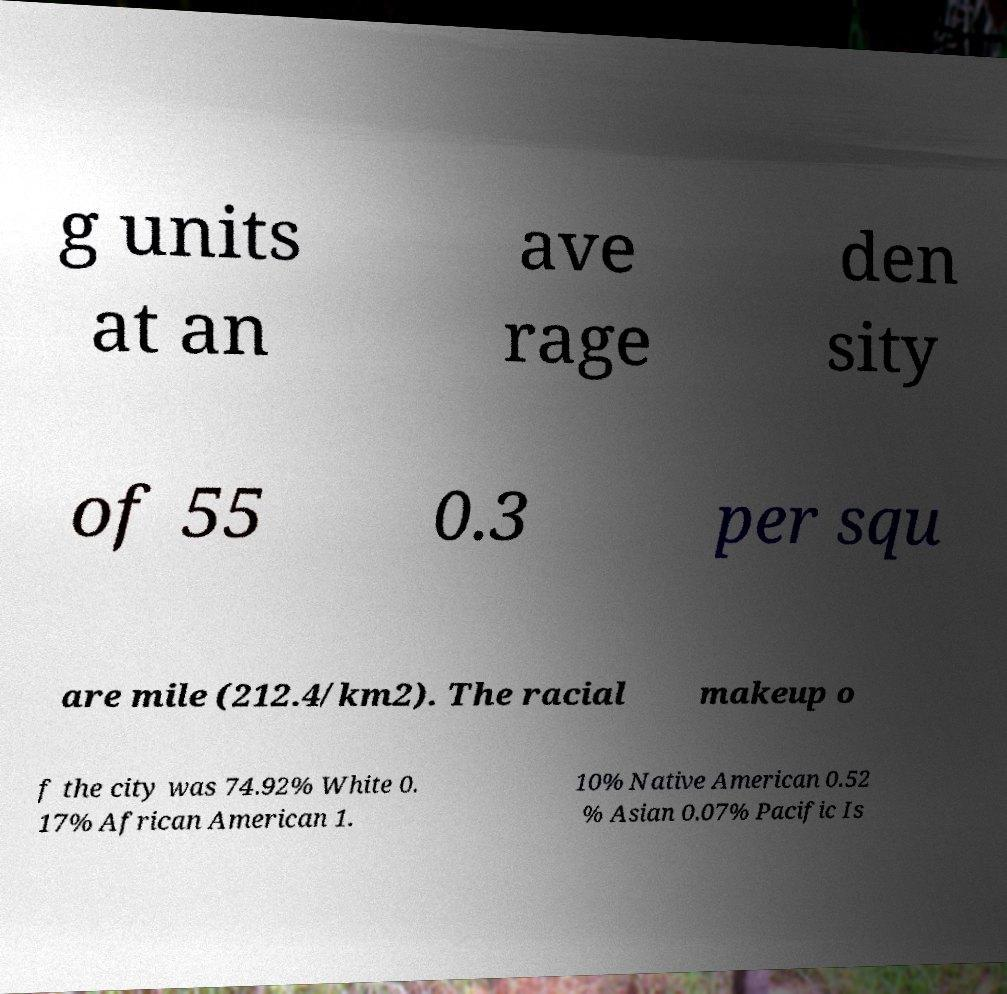There's text embedded in this image that I need extracted. Can you transcribe it verbatim? g units at an ave rage den sity of 55 0.3 per squ are mile (212.4/km2). The racial makeup o f the city was 74.92% White 0. 17% African American 1. 10% Native American 0.52 % Asian 0.07% Pacific Is 